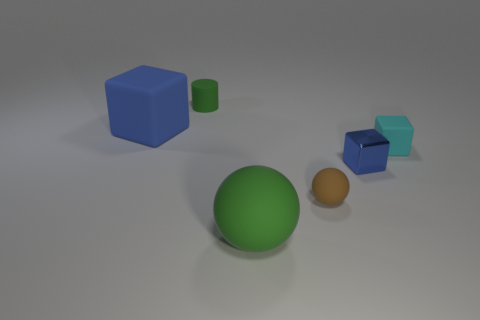Add 2 large green balls. How many objects exist? 8 Subtract all cylinders. How many objects are left? 5 Add 1 tiny green cylinders. How many tiny green cylinders exist? 2 Subtract 1 green balls. How many objects are left? 5 Subtract all tiny gray rubber objects. Subtract all cyan cubes. How many objects are left? 5 Add 6 balls. How many balls are left? 8 